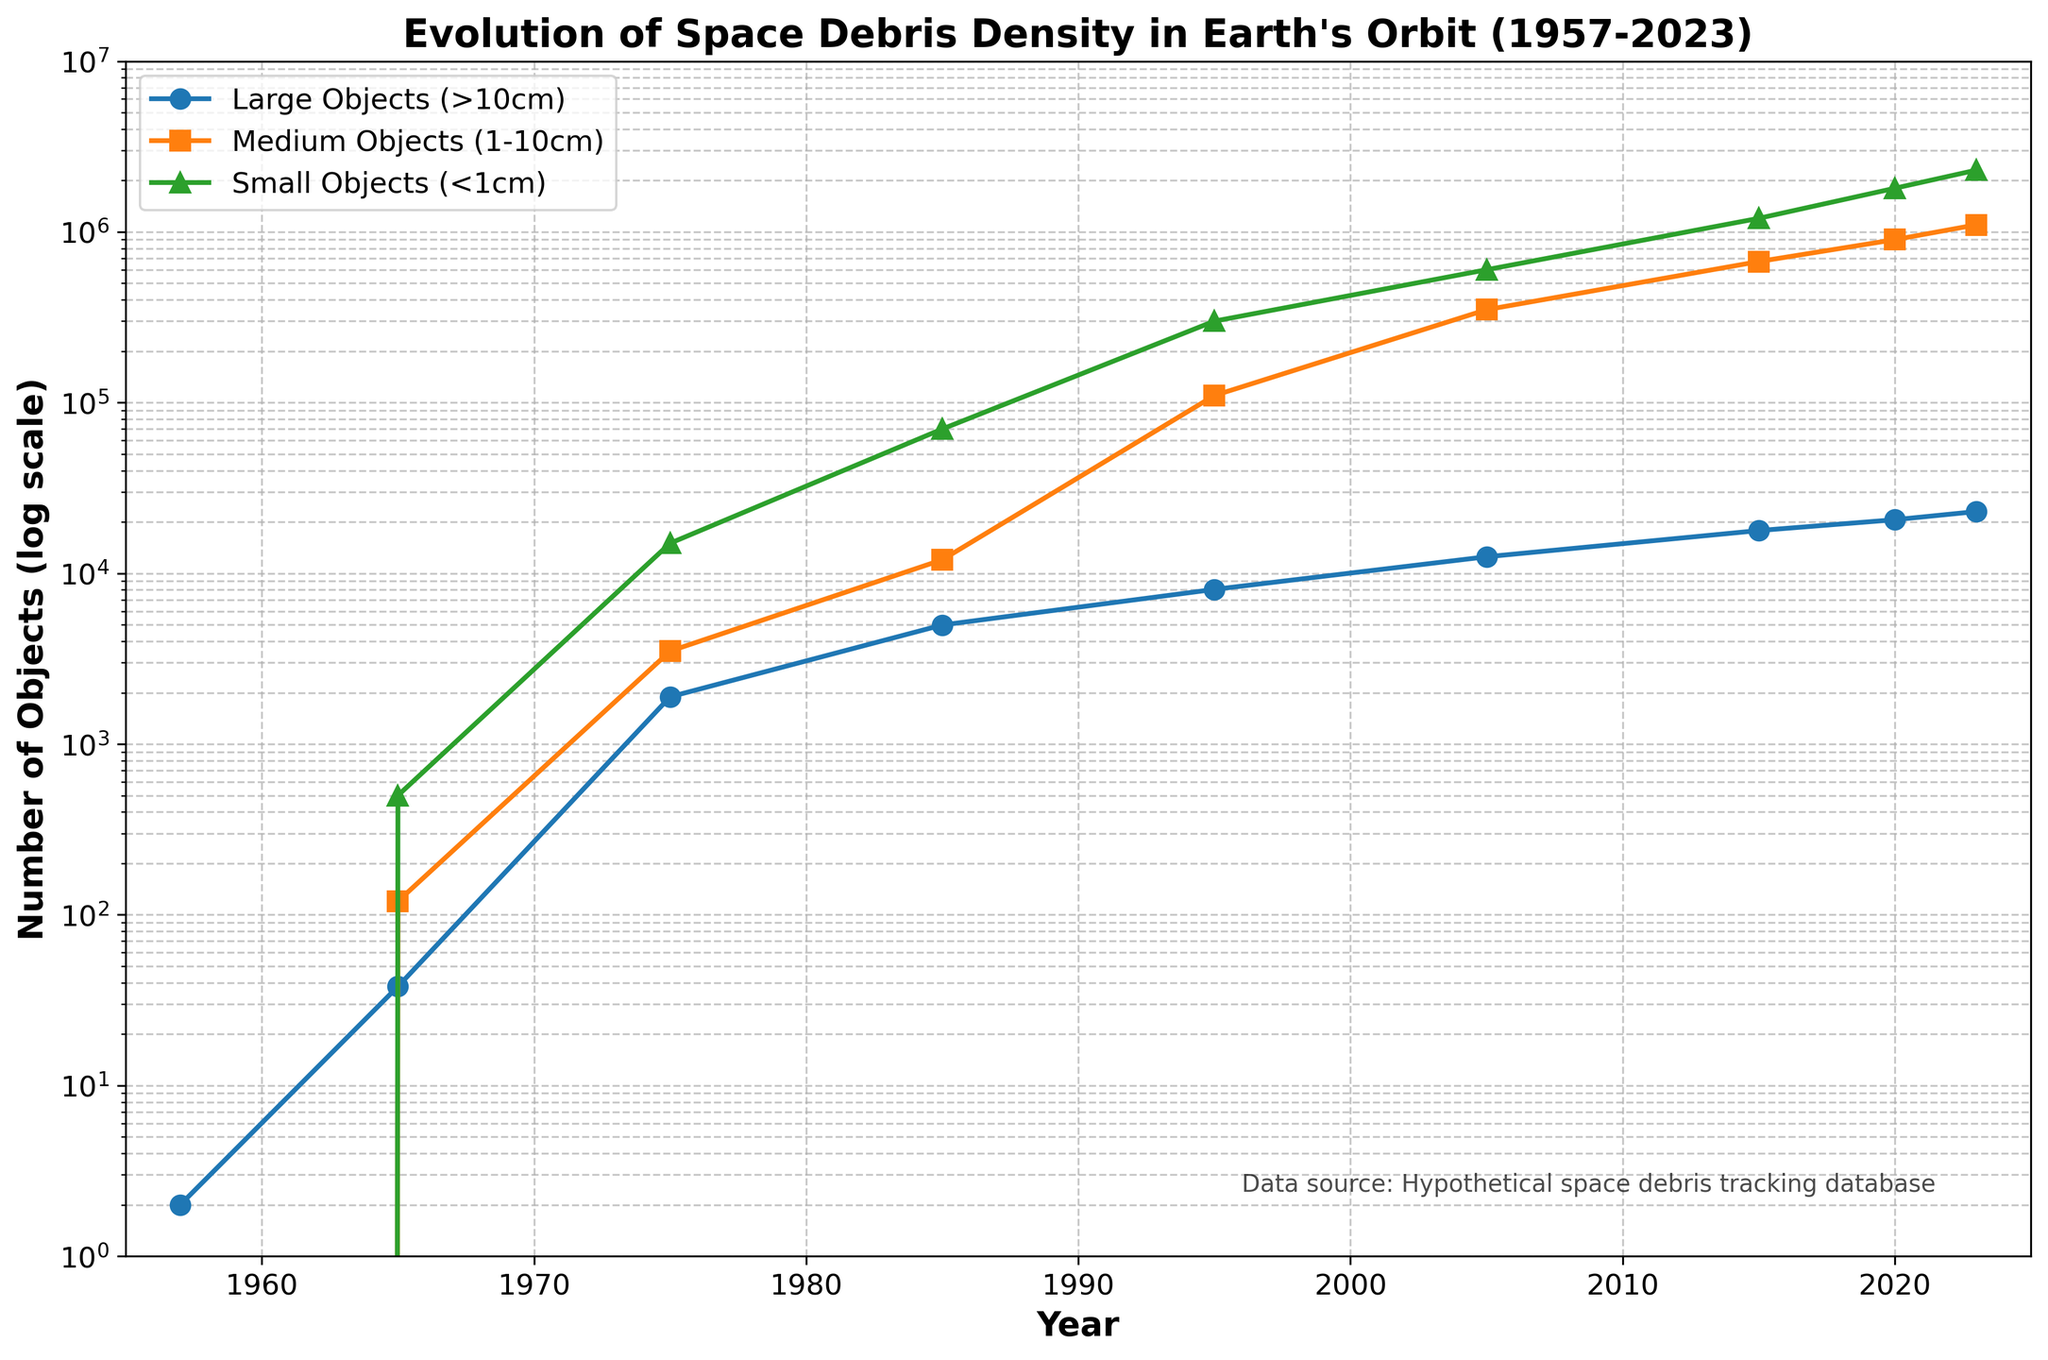How many large objects were present in Earth's orbit in 1957 and 2023 respectively? To find the number of large objects in 1957 and 2023, look at the plot for the blue line at the points corresponding to these years. In 1957, the blue line is at 2, and in 2023 it is at 23000.
Answer: 2, 23000 Which size category has the fastest growth from 1957 to 2023? Compare the lines’ slopes for each size category. The green line, which represents small objects, has the steepest slope, indicating the fastest growth.
Answer: Small Objects What’s the difference in the number of medium objects between 2015 and 2023? To find the difference, locate the points on the orange line for 2015 and 2023. In 2015, it is 670000, and in 2023, it is 1100000. Subtract 670000 from 1100000 to get the difference.
Answer: 430000 In which year did the number of large objects first surpass 10,000? Trace the blue line to find the first point where it exceeds 10,000. This happens in the year between 1995 and 2005.
Answer: Between 1995 and 2005 Which category had the highest number of objects in 2005? Compare the values of different categories in 2005 (as shown by blue, orange, and green lines). The green line representing small objects is at 600000, which is the highest.
Answer: Small Objects What is the average number of large objects from 1957 to 2023? Sum up the counts of large objects for all the years (2 + 38 + 1890 + 4980 + 8050 + 12500 + 17800 + 20600 + 23000) and divide by the number of years (9). The sum is 88960, so the average is 88960/9.
Answer: 9873.33 Is there any year where the number of medium objects was roughly equal to the number of large objects? Examine the points on the orange and blue lines to see if they ever converge. There is no year where the numbers are roughly equal visually.
Answer: No What is the trend in the number of small objects from 1985 to 2005? Look at the green line from 1985 to 2005. It shows a steep upward trend, indicating a rapid increase.
Answer: Rapid increase Which size category shows exponential growth over the years? Look at the shape of the plots on a logarithmic scale. The green line representing small objects exhibits exponential growth.
Answer: Small Objects How many more small objects are there compared to large objects in 2023? For 2023, the green line is at 2300000, and the blue line is at 23000. Subtract 23000 from 2300000.
Answer: 2277000 